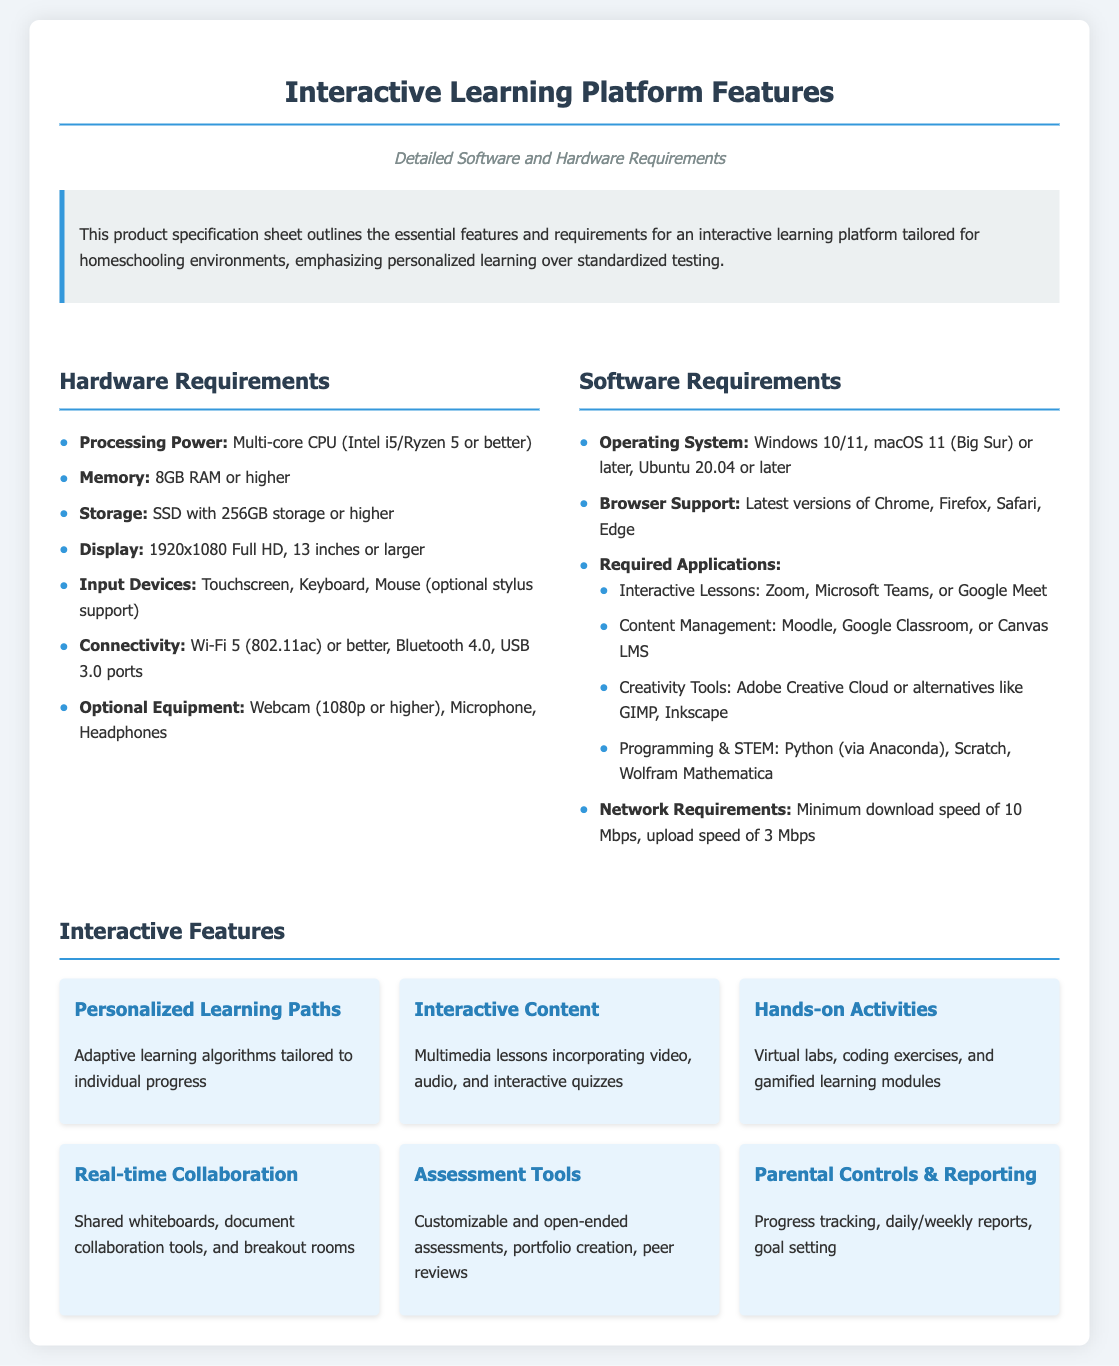What is the minimum memory requirement? The minimum memory requirement is specified as 8GB RAM or higher in the hardware section of the document.
Answer: 8GB RAM What type of CPU is recommended? The recommended CPU type is a multi-core CPU, specifically Intel i5/Ryzen 5 or better, mentioned under hardware requirements.
Answer: Multi-core CPU (Intel i5/Ryzen 5 or better) What is the required operating system? The document outlines the operating system requirement as Windows 10/11, macOS 11 (Big Sur) or later, or Ubuntu 20.04 or later.
Answer: Windows 10/11, macOS 11 (Big Sur) or later, Ubuntu 20.04 or later What is the minimum download speed needed? The minimum download speed requirement is stated as 10 Mbps in the software requirements section.
Answer: 10 Mbps Which application is required for interactive lessons? The document lists Zoom as a required application for interactive lessons in the software section.
Answer: Zoom How many interactive features are listed? The document provides a total of six interactive features in the feature section.
Answer: Six Which feature helps track progress? The feature that aids in progress tracking is "Parental Controls & Reporting," as referenced in the interactive features section.
Answer: Parental Controls & Reporting What is the resolution of the recommended display? The recommended display resolution is mentioned as 1920x1080 Full HD in the hardware requirements.
Answer: 1920x1080 Full HD What types of devices are included under input devices? The input devices specified are touchscreen, keyboard, and mouse, with optional stylus support included in the hardware requirements.
Answer: Touchscreen, Keyboard, Mouse (optional stylus support) 